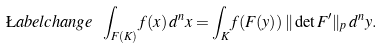<formula> <loc_0><loc_0><loc_500><loc_500>\L a b e l { c h a n g e } \ \int _ { F ( K ) } f ( x ) \, d ^ { n } x = \int _ { K } f ( F ( y ) ) \, \| \det F ^ { \prime } \| _ { p } \, d ^ { n } y .</formula> 